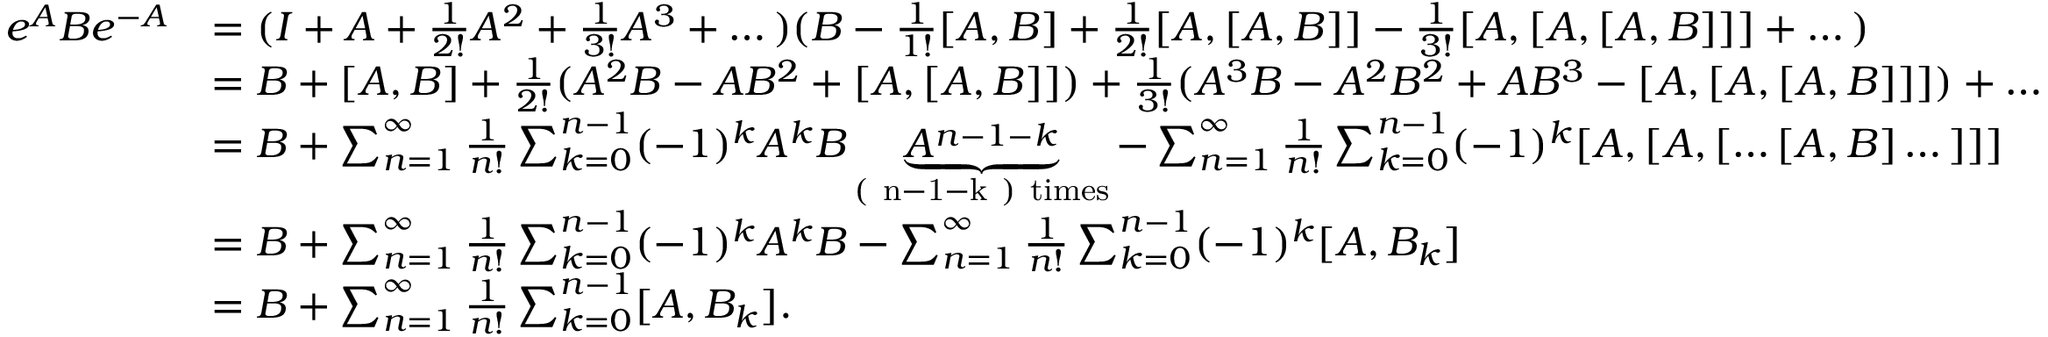Convert formula to latex. <formula><loc_0><loc_0><loc_500><loc_500>\begin{array} { r l } { e ^ { A } B e ^ { - A } } & { = ( I + A + \frac { 1 } { 2 ! } A ^ { 2 } + \frac { 1 } { 3 ! } A ^ { 3 } + \dots ) ( B - \frac { 1 } { 1 ! } [ A , B ] + \frac { 1 } { 2 ! } [ A , [ A , B ] ] - \frac { 1 } { 3 ! } [ A , [ A , [ A , B ] ] ] + \dots ) } \\ & { = B + [ A , B ] + \frac { 1 } { 2 ! } ( A ^ { 2 } B - A B ^ { 2 } + [ A , [ A , B ] ] ) + \frac { 1 } { 3 ! } ( A ^ { 3 } B - A ^ { 2 } B ^ { 2 } + A B ^ { 3 } - [ A , [ A , [ A , B ] ] ] ) + \dots } \\ & { = B + \sum _ { n = 1 } ^ { \infty } \frac { 1 } { n ! } \sum _ { k = 0 } ^ { n - 1 } ( - 1 ) ^ { k } A ^ { k } B \underbrace { A ^ { n - 1 - k } } _ { ( n - 1 - k ) t i m e s } - \sum _ { n = 1 } ^ { \infty } \frac { 1 } { n ! } \sum _ { k = 0 } ^ { n - 1 } ( - 1 ) ^ { k } [ A , [ A , [ \dots [ A , B ] \dots ] ] ] } \\ & { = B + \sum _ { n = 1 } ^ { \infty } \frac { 1 } { n ! } \sum _ { k = 0 } ^ { n - 1 } ( - 1 ) ^ { k } A ^ { k } B - \sum _ { n = 1 } ^ { \infty } \frac { 1 } { n ! } \sum _ { k = 0 } ^ { n - 1 } ( - 1 ) ^ { k } [ A , B _ { k } ] } \\ & { = B + \sum _ { n = 1 } ^ { \infty } \frac { 1 } { n ! } \sum _ { k = 0 } ^ { n - 1 } [ A , B _ { k } ] . } \end{array}</formula> 